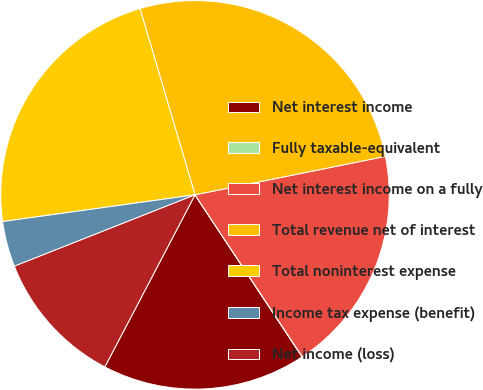Convert chart to OTSL. <chart><loc_0><loc_0><loc_500><loc_500><pie_chart><fcel>Net interest income<fcel>Fully taxable-equivalent<fcel>Net interest income on a fully<fcel>Total revenue net of interest<fcel>Total noninterest expense<fcel>Income tax expense (benefit)<fcel>Net income (loss)<nl><fcel>16.98%<fcel>0.02%<fcel>18.86%<fcel>26.4%<fcel>22.63%<fcel>3.79%<fcel>11.33%<nl></chart> 